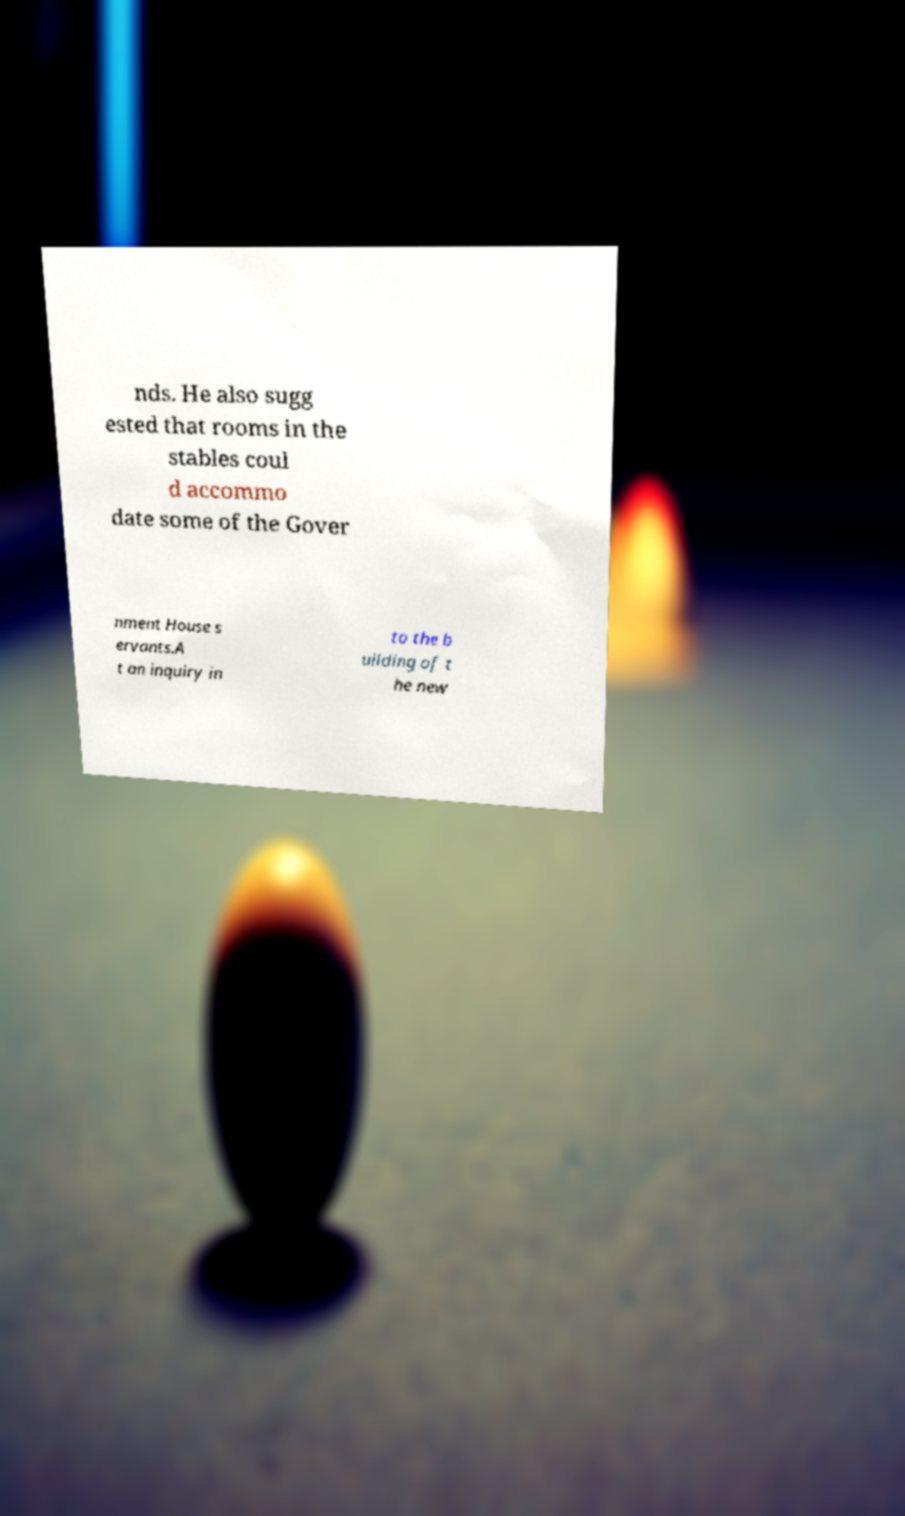For documentation purposes, I need the text within this image transcribed. Could you provide that? nds. He also sugg ested that rooms in the stables coul d accommo date some of the Gover nment House s ervants.A t an inquiry in to the b uilding of t he new 